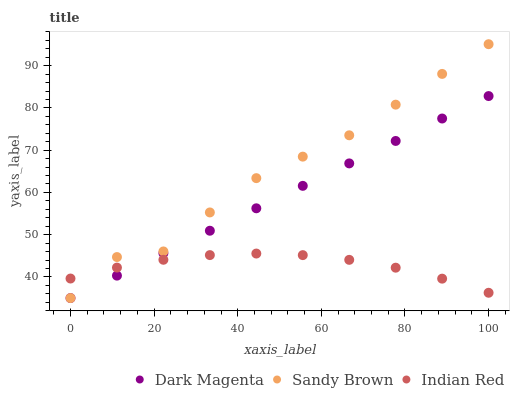Does Indian Red have the minimum area under the curve?
Answer yes or no. Yes. Does Sandy Brown have the maximum area under the curve?
Answer yes or no. Yes. Does Dark Magenta have the minimum area under the curve?
Answer yes or no. No. Does Dark Magenta have the maximum area under the curve?
Answer yes or no. No. Is Dark Magenta the smoothest?
Answer yes or no. Yes. Is Sandy Brown the roughest?
Answer yes or no. Yes. Is Indian Red the smoothest?
Answer yes or no. No. Is Indian Red the roughest?
Answer yes or no. No. Does Sandy Brown have the lowest value?
Answer yes or no. Yes. Does Indian Red have the lowest value?
Answer yes or no. No. Does Sandy Brown have the highest value?
Answer yes or no. Yes. Does Dark Magenta have the highest value?
Answer yes or no. No. Does Dark Magenta intersect Indian Red?
Answer yes or no. Yes. Is Dark Magenta less than Indian Red?
Answer yes or no. No. Is Dark Magenta greater than Indian Red?
Answer yes or no. No. 